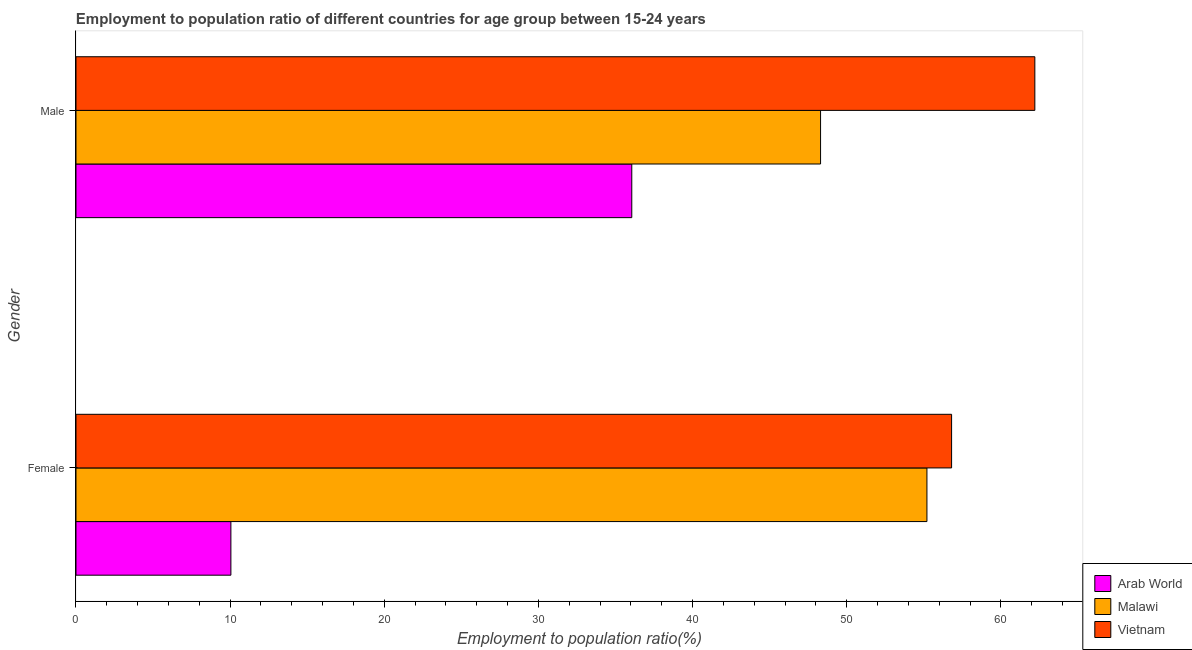How many different coloured bars are there?
Ensure brevity in your answer.  3. How many groups of bars are there?
Give a very brief answer. 2. Are the number of bars per tick equal to the number of legend labels?
Keep it short and to the point. Yes. How many bars are there on the 2nd tick from the top?
Keep it short and to the point. 3. What is the label of the 2nd group of bars from the top?
Offer a terse response. Female. What is the employment to population ratio(male) in Malawi?
Keep it short and to the point. 48.3. Across all countries, what is the maximum employment to population ratio(male)?
Provide a succinct answer. 62.2. Across all countries, what is the minimum employment to population ratio(male)?
Make the answer very short. 36.05. In which country was the employment to population ratio(male) maximum?
Your answer should be very brief. Vietnam. In which country was the employment to population ratio(male) minimum?
Ensure brevity in your answer.  Arab World. What is the total employment to population ratio(male) in the graph?
Ensure brevity in your answer.  146.55. What is the difference between the employment to population ratio(female) in Arab World and that in Malawi?
Ensure brevity in your answer.  -45.15. What is the average employment to population ratio(male) per country?
Your answer should be compact. 48.85. What is the difference between the employment to population ratio(female) and employment to population ratio(male) in Malawi?
Keep it short and to the point. 6.9. What is the ratio of the employment to population ratio(female) in Arab World to that in Vietnam?
Your answer should be very brief. 0.18. Is the employment to population ratio(male) in Arab World less than that in Vietnam?
Your answer should be very brief. Yes. In how many countries, is the employment to population ratio(male) greater than the average employment to population ratio(male) taken over all countries?
Ensure brevity in your answer.  1. What does the 1st bar from the top in Male represents?
Offer a terse response. Vietnam. What does the 2nd bar from the bottom in Male represents?
Keep it short and to the point. Malawi. How many bars are there?
Keep it short and to the point. 6. Does the graph contain any zero values?
Your answer should be very brief. No. Does the graph contain grids?
Your response must be concise. No. How many legend labels are there?
Keep it short and to the point. 3. How are the legend labels stacked?
Ensure brevity in your answer.  Vertical. What is the title of the graph?
Offer a very short reply. Employment to population ratio of different countries for age group between 15-24 years. What is the label or title of the X-axis?
Provide a short and direct response. Employment to population ratio(%). What is the Employment to population ratio(%) in Arab World in Female?
Make the answer very short. 10.05. What is the Employment to population ratio(%) of Malawi in Female?
Your answer should be compact. 55.2. What is the Employment to population ratio(%) of Vietnam in Female?
Offer a very short reply. 56.8. What is the Employment to population ratio(%) in Arab World in Male?
Ensure brevity in your answer.  36.05. What is the Employment to population ratio(%) of Malawi in Male?
Offer a very short reply. 48.3. What is the Employment to population ratio(%) of Vietnam in Male?
Offer a terse response. 62.2. Across all Gender, what is the maximum Employment to population ratio(%) in Arab World?
Make the answer very short. 36.05. Across all Gender, what is the maximum Employment to population ratio(%) in Malawi?
Provide a short and direct response. 55.2. Across all Gender, what is the maximum Employment to population ratio(%) of Vietnam?
Your answer should be very brief. 62.2. Across all Gender, what is the minimum Employment to population ratio(%) in Arab World?
Your answer should be compact. 10.05. Across all Gender, what is the minimum Employment to population ratio(%) of Malawi?
Give a very brief answer. 48.3. Across all Gender, what is the minimum Employment to population ratio(%) of Vietnam?
Offer a very short reply. 56.8. What is the total Employment to population ratio(%) of Arab World in the graph?
Provide a succinct answer. 46.1. What is the total Employment to population ratio(%) in Malawi in the graph?
Offer a terse response. 103.5. What is the total Employment to population ratio(%) in Vietnam in the graph?
Offer a very short reply. 119. What is the difference between the Employment to population ratio(%) in Arab World in Female and that in Male?
Provide a succinct answer. -26.01. What is the difference between the Employment to population ratio(%) of Malawi in Female and that in Male?
Provide a succinct answer. 6.9. What is the difference between the Employment to population ratio(%) in Arab World in Female and the Employment to population ratio(%) in Malawi in Male?
Offer a terse response. -38.25. What is the difference between the Employment to population ratio(%) in Arab World in Female and the Employment to population ratio(%) in Vietnam in Male?
Provide a short and direct response. -52.15. What is the difference between the Employment to population ratio(%) of Malawi in Female and the Employment to population ratio(%) of Vietnam in Male?
Your answer should be compact. -7. What is the average Employment to population ratio(%) of Arab World per Gender?
Give a very brief answer. 23.05. What is the average Employment to population ratio(%) in Malawi per Gender?
Your answer should be compact. 51.75. What is the average Employment to population ratio(%) of Vietnam per Gender?
Provide a succinct answer. 59.5. What is the difference between the Employment to population ratio(%) in Arab World and Employment to population ratio(%) in Malawi in Female?
Ensure brevity in your answer.  -45.15. What is the difference between the Employment to population ratio(%) in Arab World and Employment to population ratio(%) in Vietnam in Female?
Your answer should be compact. -46.75. What is the difference between the Employment to population ratio(%) of Malawi and Employment to population ratio(%) of Vietnam in Female?
Make the answer very short. -1.6. What is the difference between the Employment to population ratio(%) of Arab World and Employment to population ratio(%) of Malawi in Male?
Offer a terse response. -12.25. What is the difference between the Employment to population ratio(%) in Arab World and Employment to population ratio(%) in Vietnam in Male?
Keep it short and to the point. -26.15. What is the difference between the Employment to population ratio(%) in Malawi and Employment to population ratio(%) in Vietnam in Male?
Make the answer very short. -13.9. What is the ratio of the Employment to population ratio(%) of Arab World in Female to that in Male?
Your response must be concise. 0.28. What is the ratio of the Employment to population ratio(%) in Vietnam in Female to that in Male?
Your answer should be compact. 0.91. What is the difference between the highest and the second highest Employment to population ratio(%) in Arab World?
Keep it short and to the point. 26.01. What is the difference between the highest and the second highest Employment to population ratio(%) of Vietnam?
Your response must be concise. 5.4. What is the difference between the highest and the lowest Employment to population ratio(%) of Arab World?
Provide a succinct answer. 26.01. What is the difference between the highest and the lowest Employment to population ratio(%) in Malawi?
Keep it short and to the point. 6.9. 